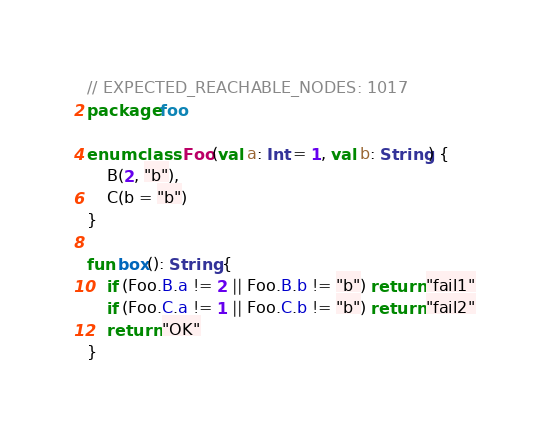Convert code to text. <code><loc_0><loc_0><loc_500><loc_500><_Kotlin_>// EXPECTED_REACHABLE_NODES: 1017
package foo

enum class Foo(val a: Int = 1, val b: String) {
    B(2, "b"),
    C(b = "b")
}

fun box(): String {
    if (Foo.B.a != 2 || Foo.B.b != "b") return "fail1"
    if (Foo.C.a != 1 || Foo.C.b != "b") return "fail2"
    return "OK"
}
</code> 